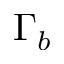<formula> <loc_0><loc_0><loc_500><loc_500>\Gamma _ { b }</formula> 